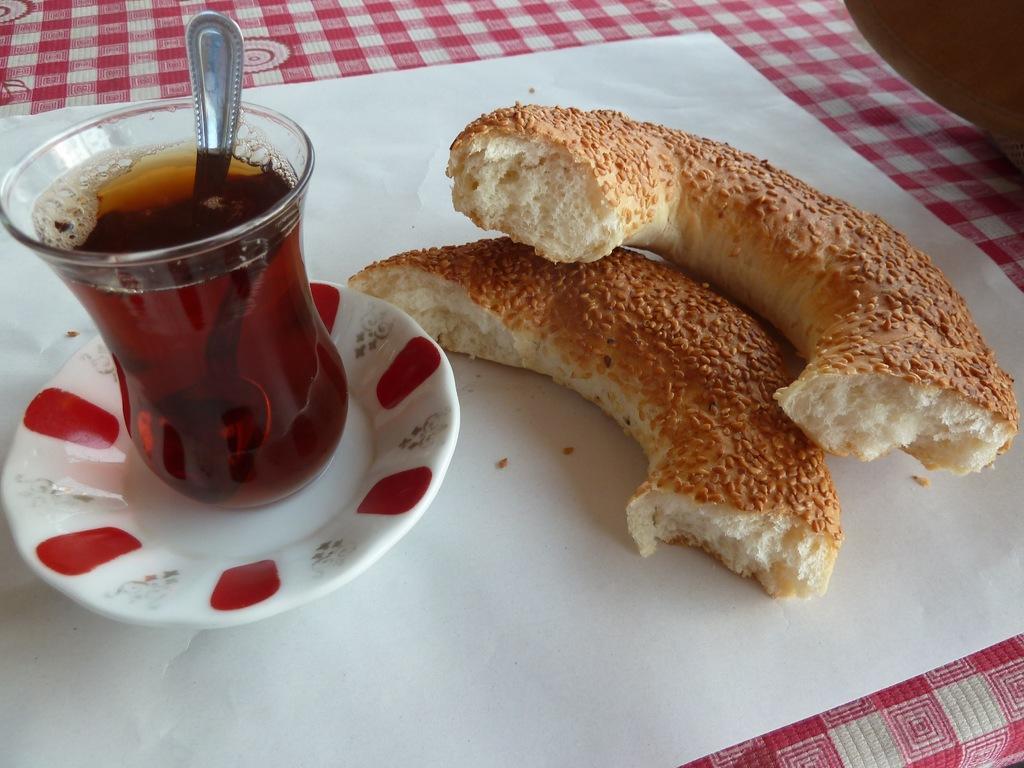Can you describe this image briefly? In this image I can see on the left side there is a liquid in a glass and a spoon. On the right side there are food items. 